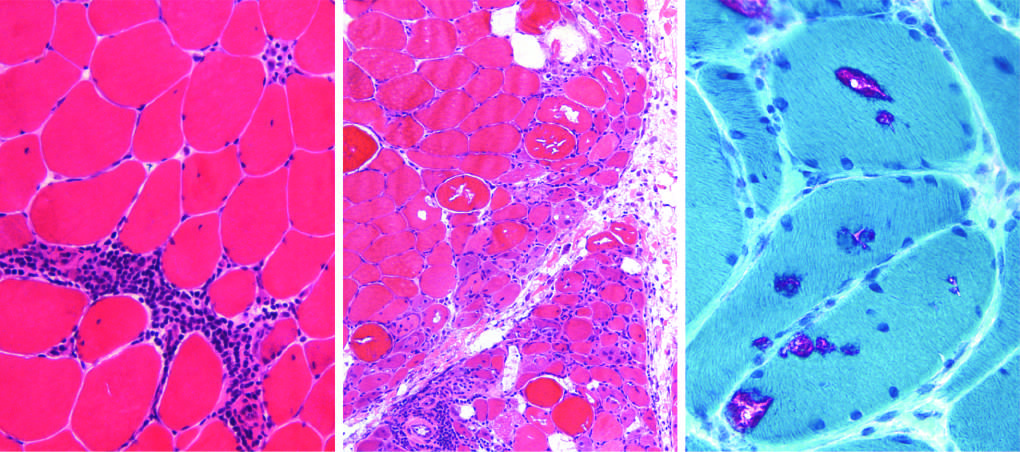s the gland characterized by endomysial inflammatory infiltrates and myofiber necrosis (arrow)?
Answer the question using a single word or phrase. No 